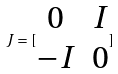<formula> <loc_0><loc_0><loc_500><loc_500>J = [ \begin{matrix} 0 & I \\ - I & 0 \end{matrix} ]</formula> 